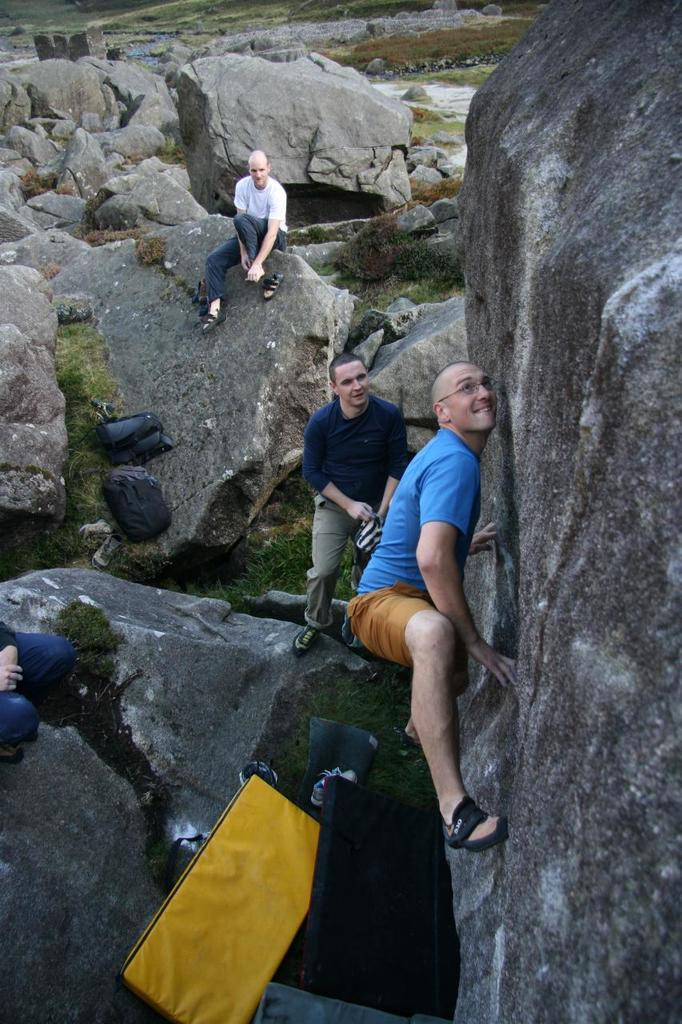How many people are in the image? There are four persons in the image. What is one person doing in the image? One person is climbing. What can be seen in the image besides the people? There are bags, rocks, and grass in the image. Can you describe the environment in the image? The environment includes rocks and grass, suggesting an outdoor setting. What type of drawer can be seen in the image? There is no drawer present in the image. What kind of stone is being used to build the structure in the image? There is no structure or stone visible in the image. 